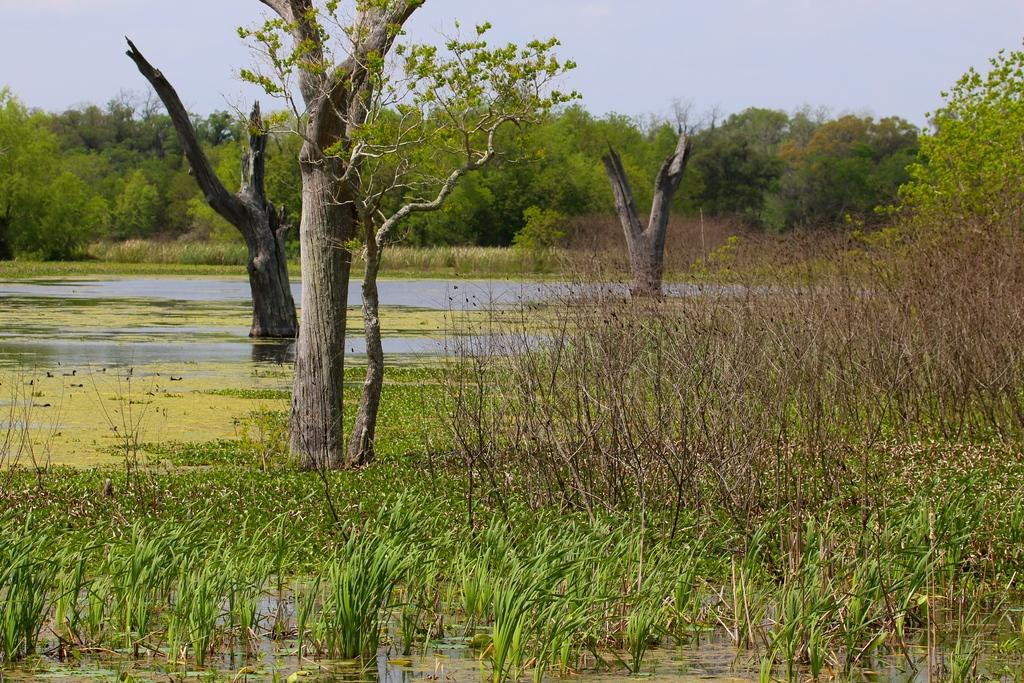What type of vegetation can be seen in the image? There is grass, plants, and trees in the image. What natural element is present in the image besides vegetation? The surface of the water is visible in the image. What can be seen in the background of the image? The sky is visible in the background of the image. How many crows are perched on the trees in the image? There are no crows present in the image; it only features vegetation, water, and the sky. 